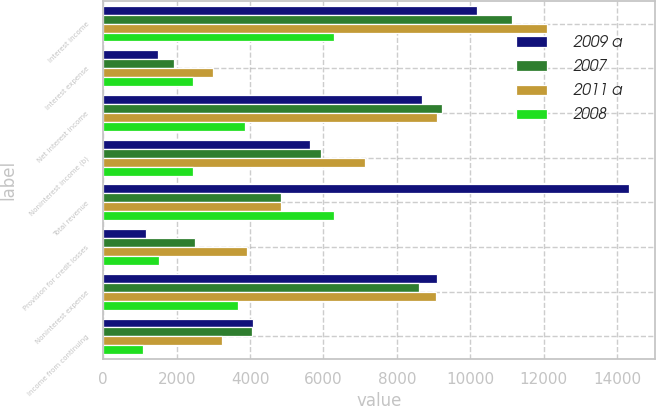Convert chart to OTSL. <chart><loc_0><loc_0><loc_500><loc_500><stacked_bar_chart><ecel><fcel>Interest income<fcel>Interest expense<fcel>Net interest income<fcel>Noninterest income (b)<fcel>Total revenue<fcel>Provision for credit losses<fcel>Noninterest expense<fcel>Income from continuing<nl><fcel>2009 a<fcel>10194<fcel>1494<fcel>8700<fcel>5626<fcel>14326<fcel>1152<fcel>9105<fcel>4069<nl><fcel>2007<fcel>11150<fcel>1920<fcel>9230<fcel>5946<fcel>4847.5<fcel>2502<fcel>8613<fcel>4061<nl><fcel>2011 a<fcel>12086<fcel>3003<fcel>9083<fcel>7145<fcel>4847.5<fcel>3930<fcel>9073<fcel>3225<nl><fcel>2008<fcel>6301<fcel>2447<fcel>3854<fcel>2442<fcel>6296<fcel>1517<fcel>3685<fcel>1094<nl></chart> 